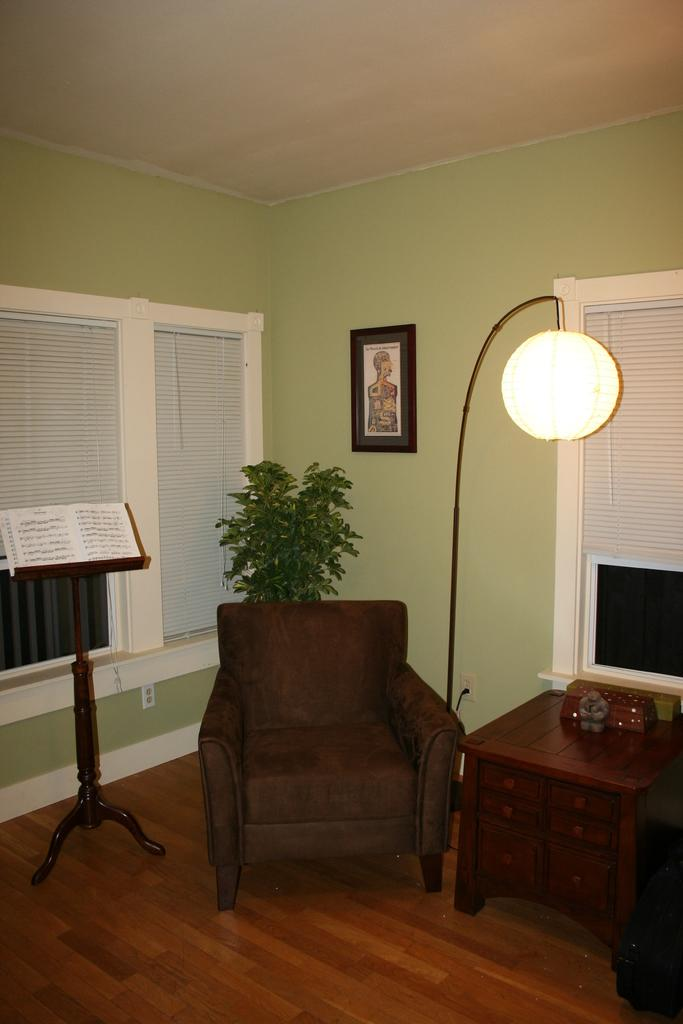What type of furniture is present in the image? There is a chair and a table in the image. What other object can be seen in the image? There is a stand in the image. What is the source of light in the image? There is a light in the image. What type of structure surrounds the objects in the image? There are walls in the image. What type of decorative item is present in the image? There is a photo frame in the image. What type of chicken is depicted in the photo frame in the image? There is no chicken present in the image, nor is there a photo frame depicting a chicken. 